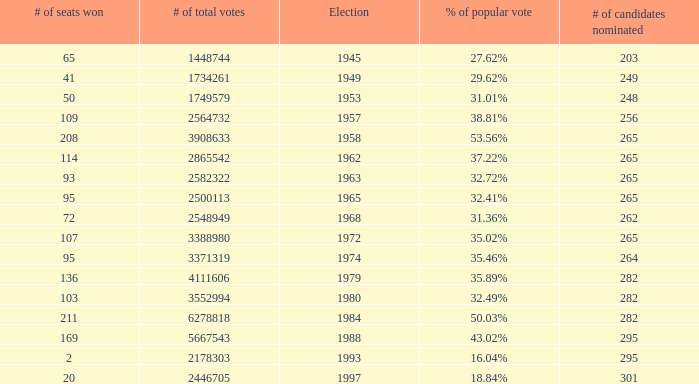What year was the election when the # of seats won was 65? 1945.0. 